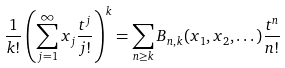Convert formula to latex. <formula><loc_0><loc_0><loc_500><loc_500>\frac { 1 } { k ! } \left ( \sum _ { j = 1 } ^ { \infty } x _ { j } \frac { t ^ { j } } { j ! } \right ) ^ { k } = \sum _ { n \geq k } B _ { n , k } ( x _ { 1 } , x _ { 2 } , \dots ) \frac { t ^ { n } } { n ! }</formula> 